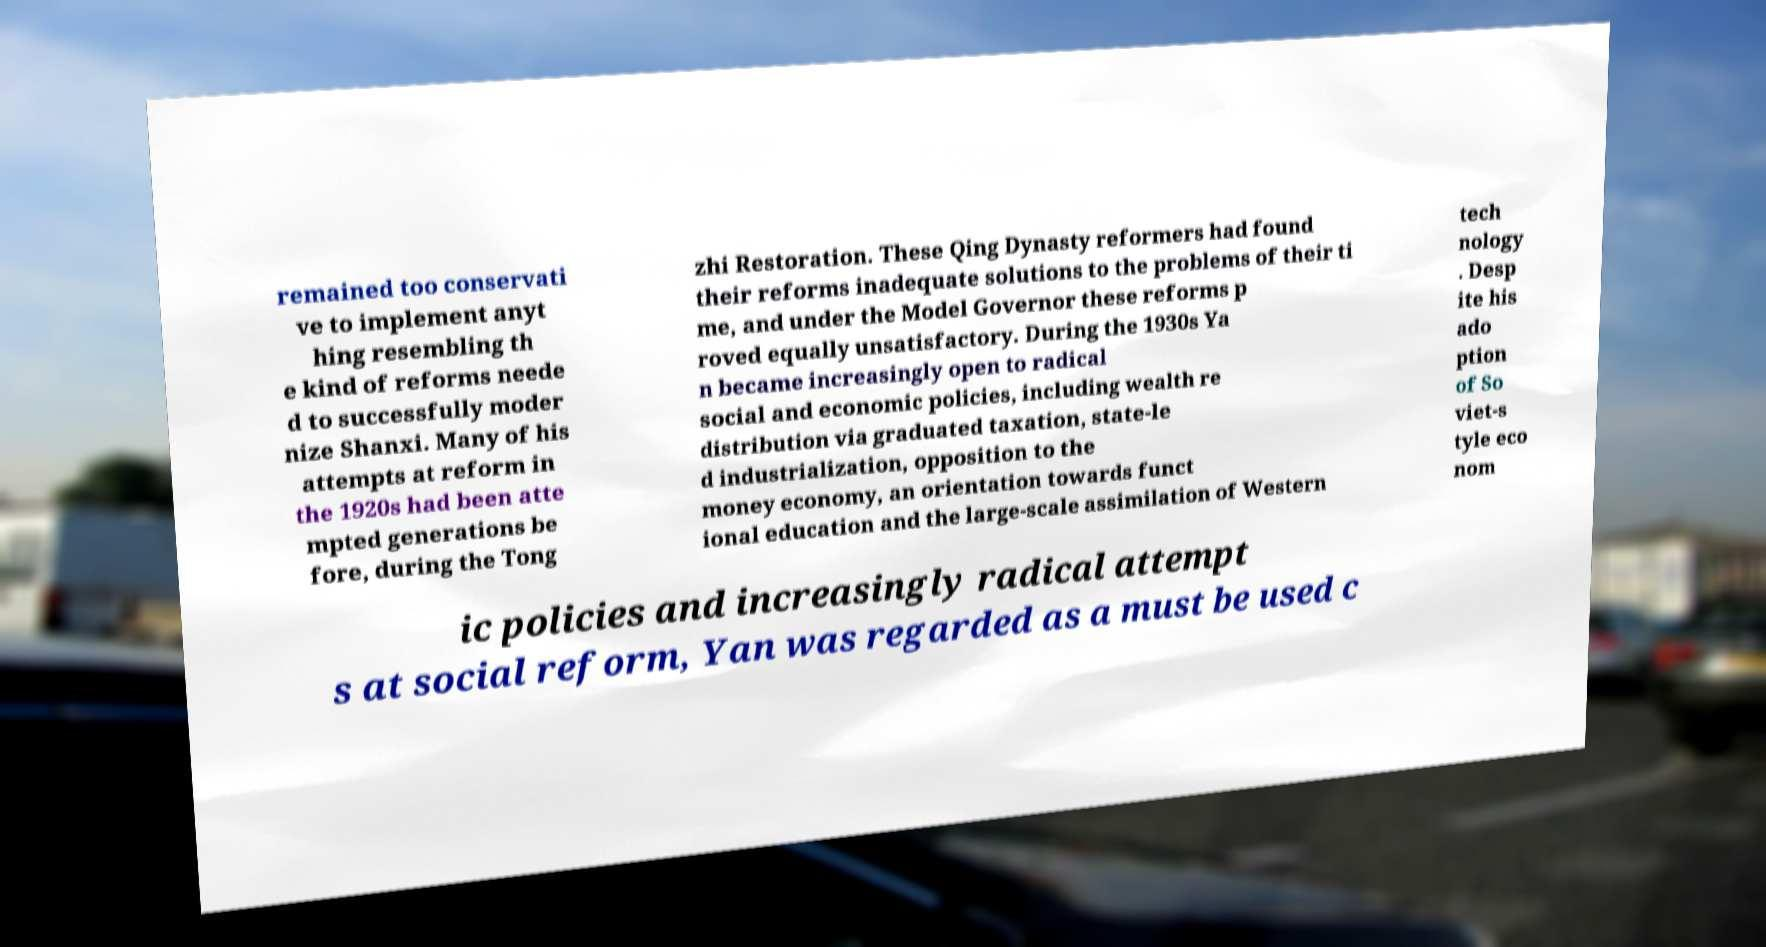Can you accurately transcribe the text from the provided image for me? remained too conservati ve to implement anyt hing resembling th e kind of reforms neede d to successfully moder nize Shanxi. Many of his attempts at reform in the 1920s had been atte mpted generations be fore, during the Tong zhi Restoration. These Qing Dynasty reformers had found their reforms inadequate solutions to the problems of their ti me, and under the Model Governor these reforms p roved equally unsatisfactory. During the 1930s Ya n became increasingly open to radical social and economic policies, including wealth re distribution via graduated taxation, state-le d industrialization, opposition to the money economy, an orientation towards funct ional education and the large-scale assimilation of Western tech nology . Desp ite his ado ption of So viet-s tyle eco nom ic policies and increasingly radical attempt s at social reform, Yan was regarded as a must be used c 